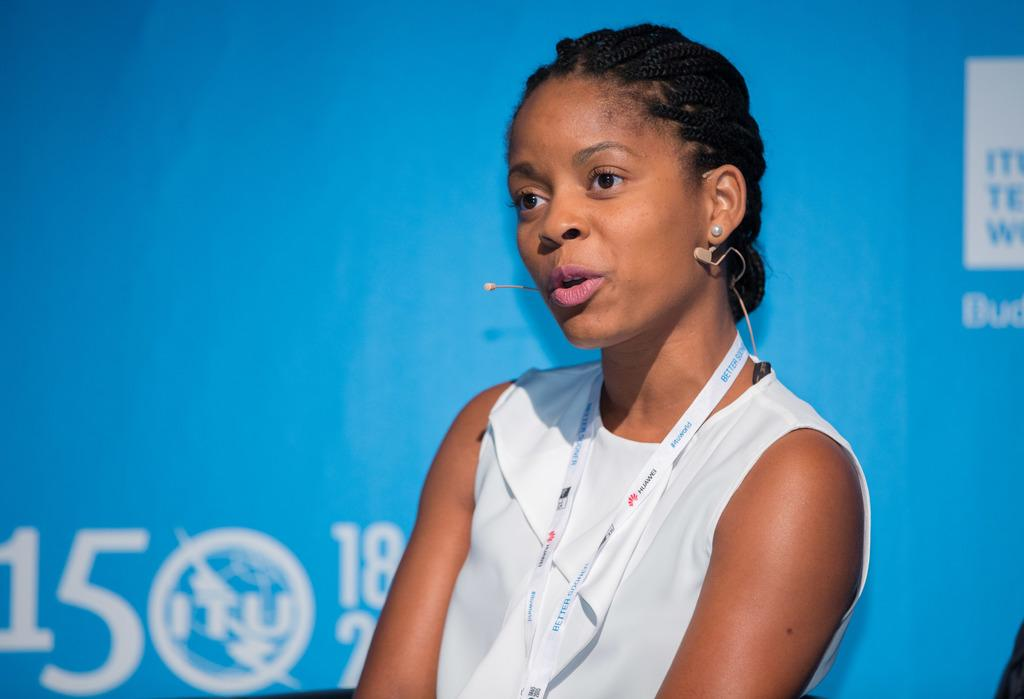Who or what is in the image? There is a person in the image. What is the person wearing? The person is wearing a white dress. What can be seen in the background of the image? There is a blue board in the background. What is the color of the object on the blue board? There is something with a white color on the board. What type of yam is being cooked in the oven in the image? There is no yam or oven present in the image. What adjustments need to be made to the person's dress in the image? There is no need for adjustments to the person's dress in the image, as it is already visible and described as white. 